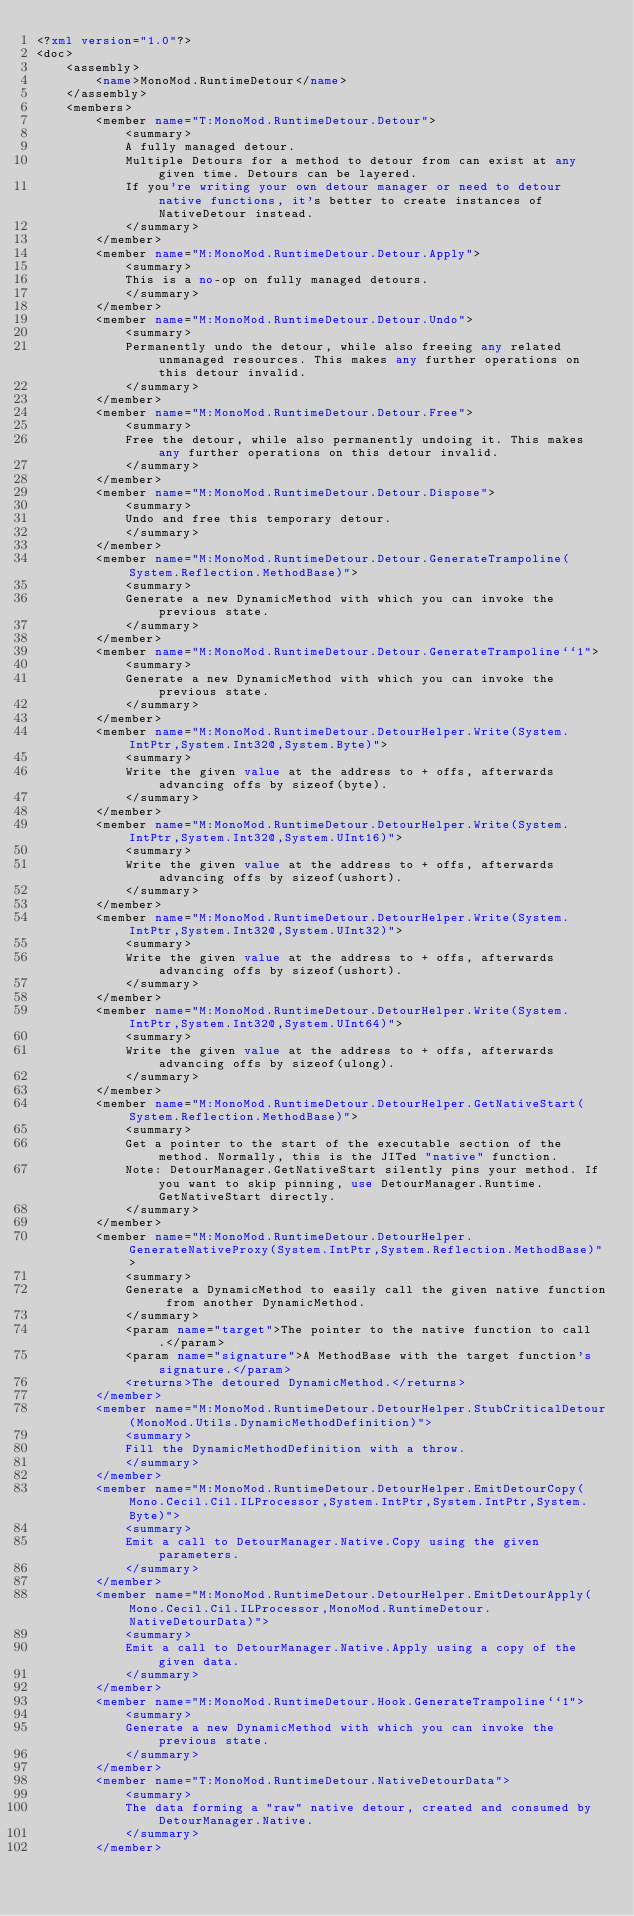Convert code to text. <code><loc_0><loc_0><loc_500><loc_500><_XML_><?xml version="1.0"?>
<doc>
    <assembly>
        <name>MonoMod.RuntimeDetour</name>
    </assembly>
    <members>
        <member name="T:MonoMod.RuntimeDetour.Detour">
            <summary>
            A fully managed detour.
            Multiple Detours for a method to detour from can exist at any given time. Detours can be layered.
            If you're writing your own detour manager or need to detour native functions, it's better to create instances of NativeDetour instead.
            </summary>
        </member>
        <member name="M:MonoMod.RuntimeDetour.Detour.Apply">
            <summary>
            This is a no-op on fully managed detours.
            </summary>
        </member>
        <member name="M:MonoMod.RuntimeDetour.Detour.Undo">
            <summary>
            Permanently undo the detour, while also freeing any related unmanaged resources. This makes any further operations on this detour invalid.
            </summary>
        </member>
        <member name="M:MonoMod.RuntimeDetour.Detour.Free">
            <summary>
            Free the detour, while also permanently undoing it. This makes any further operations on this detour invalid.
            </summary>
        </member>
        <member name="M:MonoMod.RuntimeDetour.Detour.Dispose">
            <summary>
            Undo and free this temporary detour.
            </summary>
        </member>
        <member name="M:MonoMod.RuntimeDetour.Detour.GenerateTrampoline(System.Reflection.MethodBase)">
            <summary>
            Generate a new DynamicMethod with which you can invoke the previous state.
            </summary>
        </member>
        <member name="M:MonoMod.RuntimeDetour.Detour.GenerateTrampoline``1">
            <summary>
            Generate a new DynamicMethod with which you can invoke the previous state.
            </summary>
        </member>
        <member name="M:MonoMod.RuntimeDetour.DetourHelper.Write(System.IntPtr,System.Int32@,System.Byte)">
            <summary>
            Write the given value at the address to + offs, afterwards advancing offs by sizeof(byte).
            </summary>
        </member>
        <member name="M:MonoMod.RuntimeDetour.DetourHelper.Write(System.IntPtr,System.Int32@,System.UInt16)">
            <summary>
            Write the given value at the address to + offs, afterwards advancing offs by sizeof(ushort).
            </summary>
        </member>
        <member name="M:MonoMod.RuntimeDetour.DetourHelper.Write(System.IntPtr,System.Int32@,System.UInt32)">
            <summary>
            Write the given value at the address to + offs, afterwards advancing offs by sizeof(ushort).
            </summary>
        </member>
        <member name="M:MonoMod.RuntimeDetour.DetourHelper.Write(System.IntPtr,System.Int32@,System.UInt64)">
            <summary>
            Write the given value at the address to + offs, afterwards advancing offs by sizeof(ulong).
            </summary>
        </member>
        <member name="M:MonoMod.RuntimeDetour.DetourHelper.GetNativeStart(System.Reflection.MethodBase)">
            <summary>
            Get a pointer to the start of the executable section of the method. Normally, this is the JITed "native" function.
            Note: DetourManager.GetNativeStart silently pins your method. If you want to skip pinning, use DetourManager.Runtime.GetNativeStart directly.
            </summary>
        </member>
        <member name="M:MonoMod.RuntimeDetour.DetourHelper.GenerateNativeProxy(System.IntPtr,System.Reflection.MethodBase)">
            <summary>
            Generate a DynamicMethod to easily call the given native function from another DynamicMethod.
            </summary>
            <param name="target">The pointer to the native function to call.</param>
            <param name="signature">A MethodBase with the target function's signature.</param>
            <returns>The detoured DynamicMethod.</returns>
        </member>
        <member name="M:MonoMod.RuntimeDetour.DetourHelper.StubCriticalDetour(MonoMod.Utils.DynamicMethodDefinition)">
            <summary>
            Fill the DynamicMethodDefinition with a throw.
            </summary>
        </member>
        <member name="M:MonoMod.RuntimeDetour.DetourHelper.EmitDetourCopy(Mono.Cecil.Cil.ILProcessor,System.IntPtr,System.IntPtr,System.Byte)">
            <summary>
            Emit a call to DetourManager.Native.Copy using the given parameters.
            </summary>
        </member>
        <member name="M:MonoMod.RuntimeDetour.DetourHelper.EmitDetourApply(Mono.Cecil.Cil.ILProcessor,MonoMod.RuntimeDetour.NativeDetourData)">
            <summary>
            Emit a call to DetourManager.Native.Apply using a copy of the given data.
            </summary>
        </member>
        <member name="M:MonoMod.RuntimeDetour.Hook.GenerateTrampoline``1">
            <summary>
            Generate a new DynamicMethod with which you can invoke the previous state.
            </summary>
        </member>
        <member name="T:MonoMod.RuntimeDetour.NativeDetourData">
            <summary>
            The data forming a "raw" native detour, created and consumed by DetourManager.Native.
            </summary>
        </member></code> 